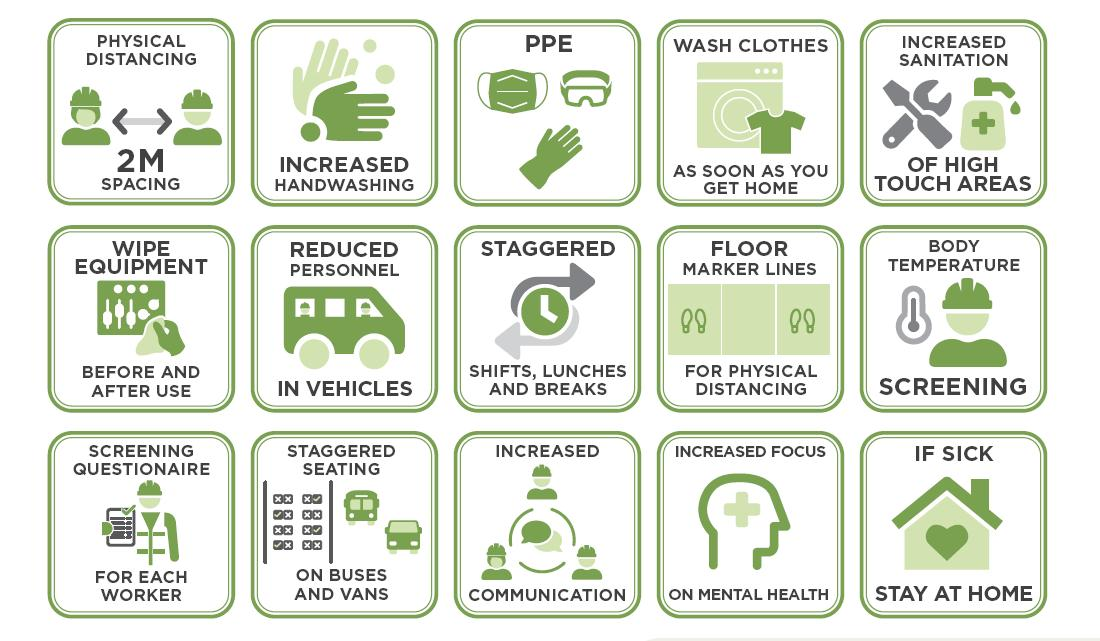Give some essential details in this illustration. If a person is sick, it is advisable for them to stay at home in order to recover. I declare that the phrase 'What includes masks, goggles and gloves? PPE..' refers to the use of personal protective equipment (PPE) such as masks, goggles, and gloves to protect individuals from potential harm. Spacing individuals at 2 meters helps to maintain physical distancing, which is critical for personal safety and hygiene in crowded public gathering spaces. To prevent the spread of bacteria and viruses in high-touch areas, increased sanitation measures must be implemented. The purpose of floor marker lines in COVID-19 prevention is to facilitate physical distancing between individuals in order to reduce the spread of the virus. 